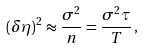Convert formula to latex. <formula><loc_0><loc_0><loc_500><loc_500>( \delta \eta ) ^ { 2 } \approx \frac { \sigma ^ { 2 } } { n } = \frac { \sigma ^ { 2 } \tau } { T } \, ,</formula> 